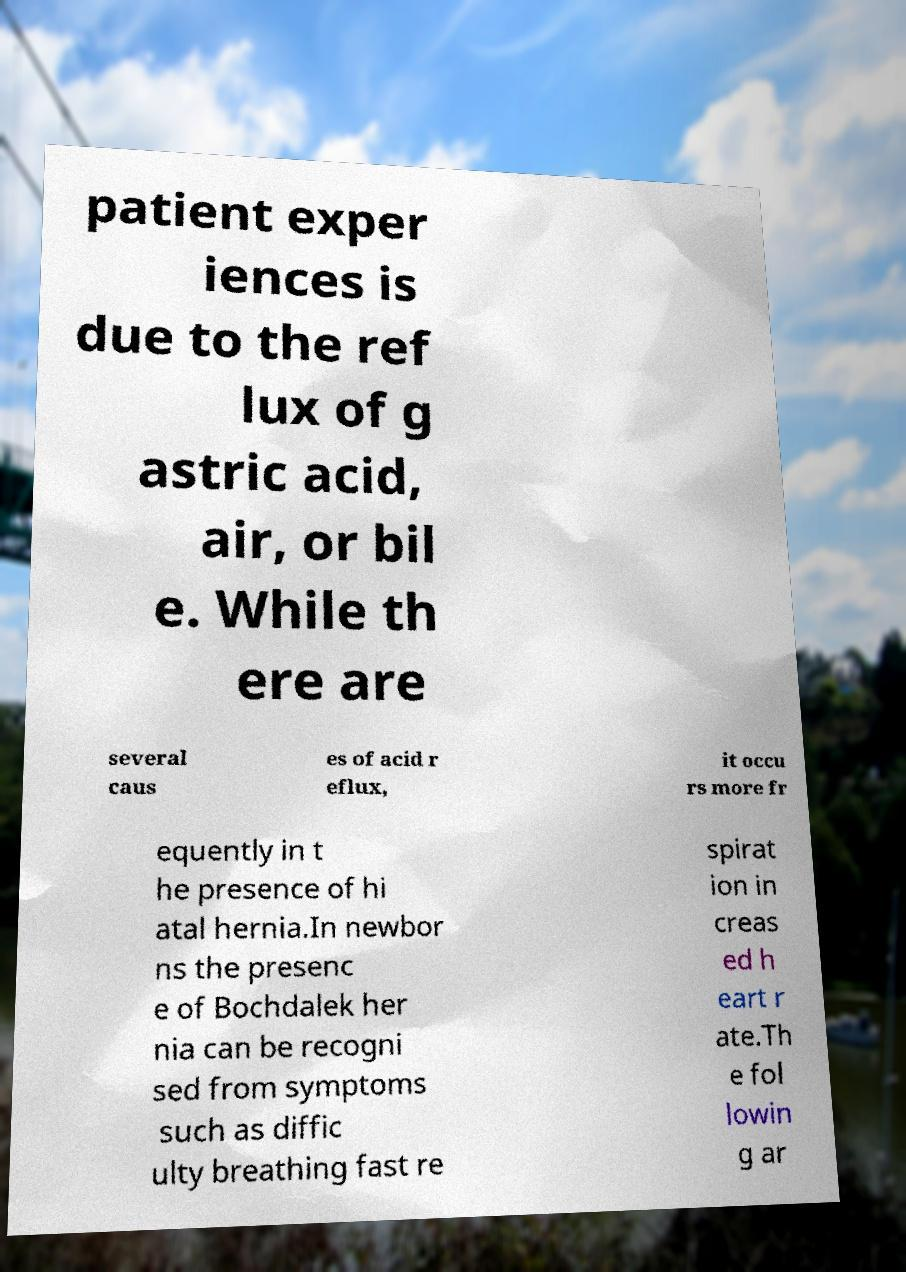Can you accurately transcribe the text from the provided image for me? patient exper iences is due to the ref lux of g astric acid, air, or bil e. While th ere are several caus es of acid r eflux, it occu rs more fr equently in t he presence of hi atal hernia.In newbor ns the presenc e of Bochdalek her nia can be recogni sed from symptoms such as diffic ulty breathing fast re spirat ion in creas ed h eart r ate.Th e fol lowin g ar 